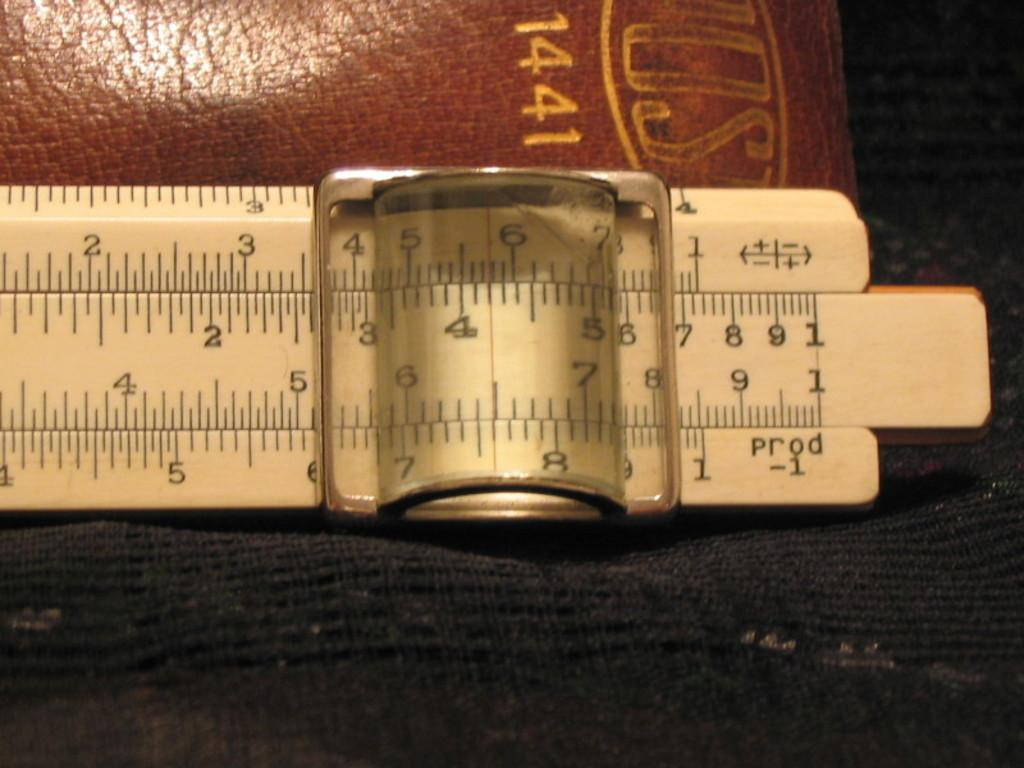Provide a one-sentence caption for the provided image. A slide rule in front of a leather bound book that says 1441. 